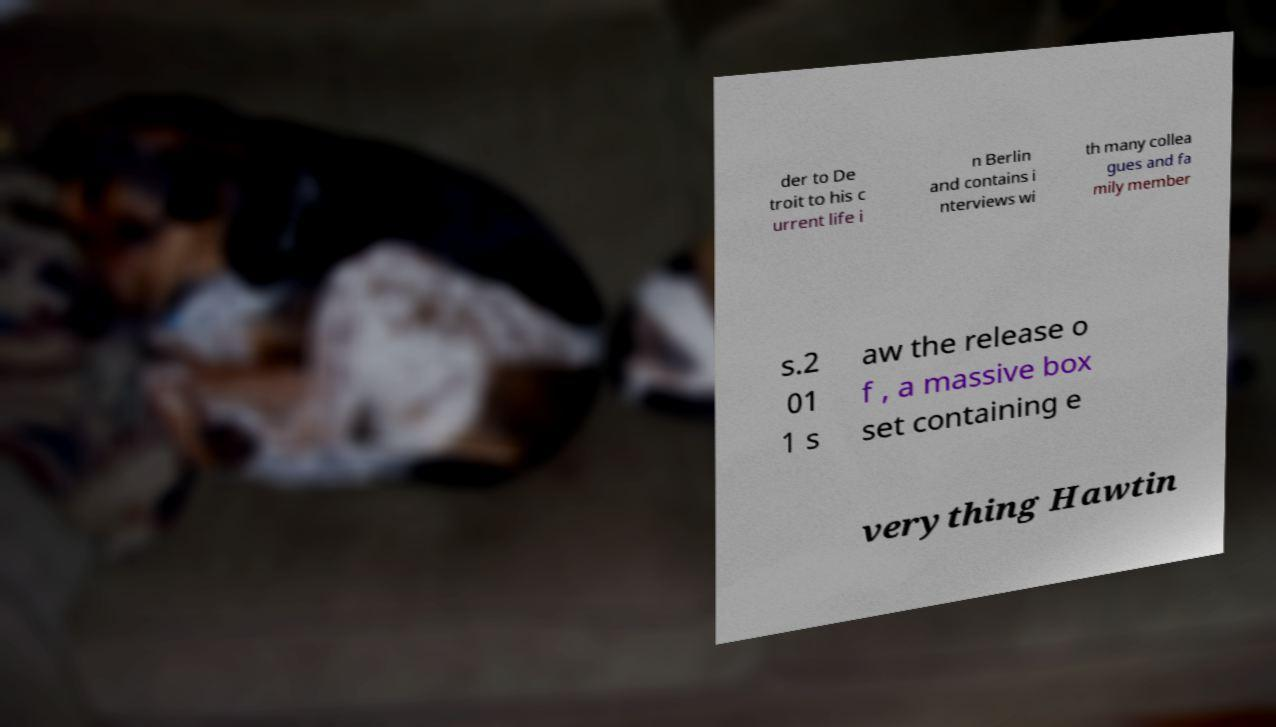There's text embedded in this image that I need extracted. Can you transcribe it verbatim? der to De troit to his c urrent life i n Berlin and contains i nterviews wi th many collea gues and fa mily member s.2 01 1 s aw the release o f , a massive box set containing e verything Hawtin 